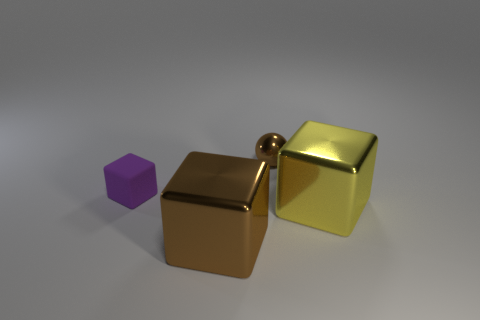Is there anything else that has the same color as the small matte thing?
Your response must be concise. No. How big is the metallic thing that is in front of the purple object and left of the yellow object?
Your response must be concise. Large. Is there a cube that is behind the brown metallic thing that is on the left side of the brown thing to the right of the big brown metallic cube?
Keep it short and to the point. Yes. Are any tiny metallic balls visible?
Make the answer very short. Yes. Is the number of yellow objects that are right of the small matte thing greater than the number of large things that are on the right side of the large yellow metallic thing?
Offer a very short reply. Yes. What is the size of the brown cube that is the same material as the yellow object?
Keep it short and to the point. Large. What is the size of the brown shiny object to the left of the small object behind the small purple matte thing behind the big yellow metallic block?
Keep it short and to the point. Large. There is a big shiny block that is on the right side of the big brown block; what is its color?
Provide a short and direct response. Yellow. Is the number of yellow objects in front of the purple matte cube greater than the number of small yellow balls?
Offer a very short reply. Yes. Do the big thing to the right of the big brown cube and the large brown metal object have the same shape?
Offer a terse response. Yes. 